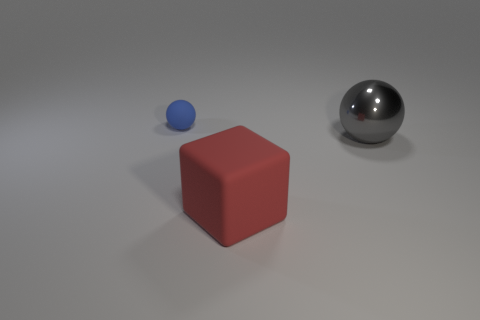Is the gray metal object the same shape as the big rubber object?
Keep it short and to the point. No. The rubber object that is the same shape as the big gray shiny object is what size?
Your answer should be compact. Small. The object left of the large red thing has what shape?
Provide a succinct answer. Sphere. There is a shiny object; is it the same shape as the matte thing behind the red object?
Make the answer very short. Yes. Is the number of tiny rubber objects in front of the large gray metal ball the same as the number of blue matte spheres in front of the red rubber object?
Your response must be concise. Yes. There is a rubber thing that is in front of the large metal sphere; does it have the same color as the ball that is to the right of the tiny thing?
Provide a succinct answer. No. Is the number of tiny blue objects in front of the red matte object greater than the number of tiny brown metallic blocks?
Ensure brevity in your answer.  No. What is the material of the small blue sphere?
Ensure brevity in your answer.  Rubber. There is a thing that is the same material as the tiny ball; what shape is it?
Provide a short and direct response. Cube. What is the size of the rubber object that is behind the big object in front of the big gray object?
Offer a very short reply. Small. 